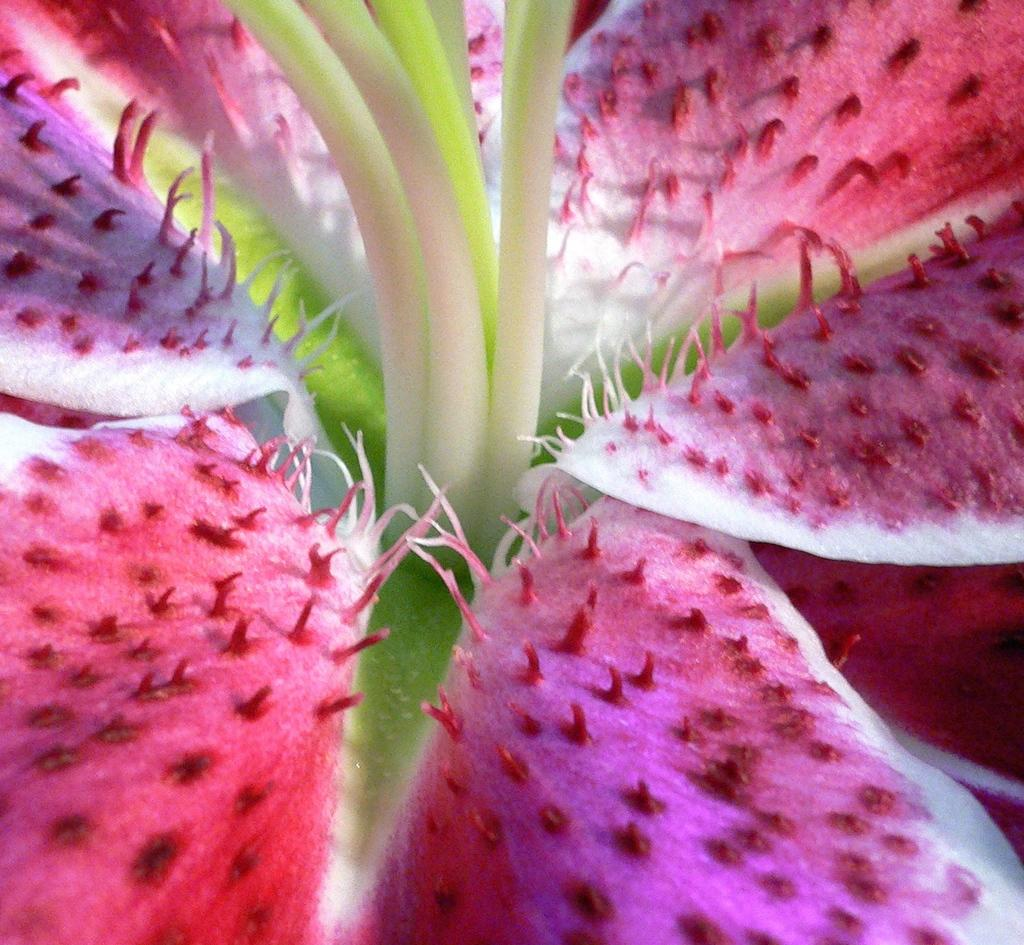What is the main subject of the image? The main subject of the image is a flower. Can you describe the flower in the image? The image is a zoomed-in picture of a flower, so it provides a close-up view of the flower's petals, stem, and other details. What type of protest is happening in the room with the oven in the image? There is no room, oven, or protest present in the image; it is a zoomed-in picture of a flower. 